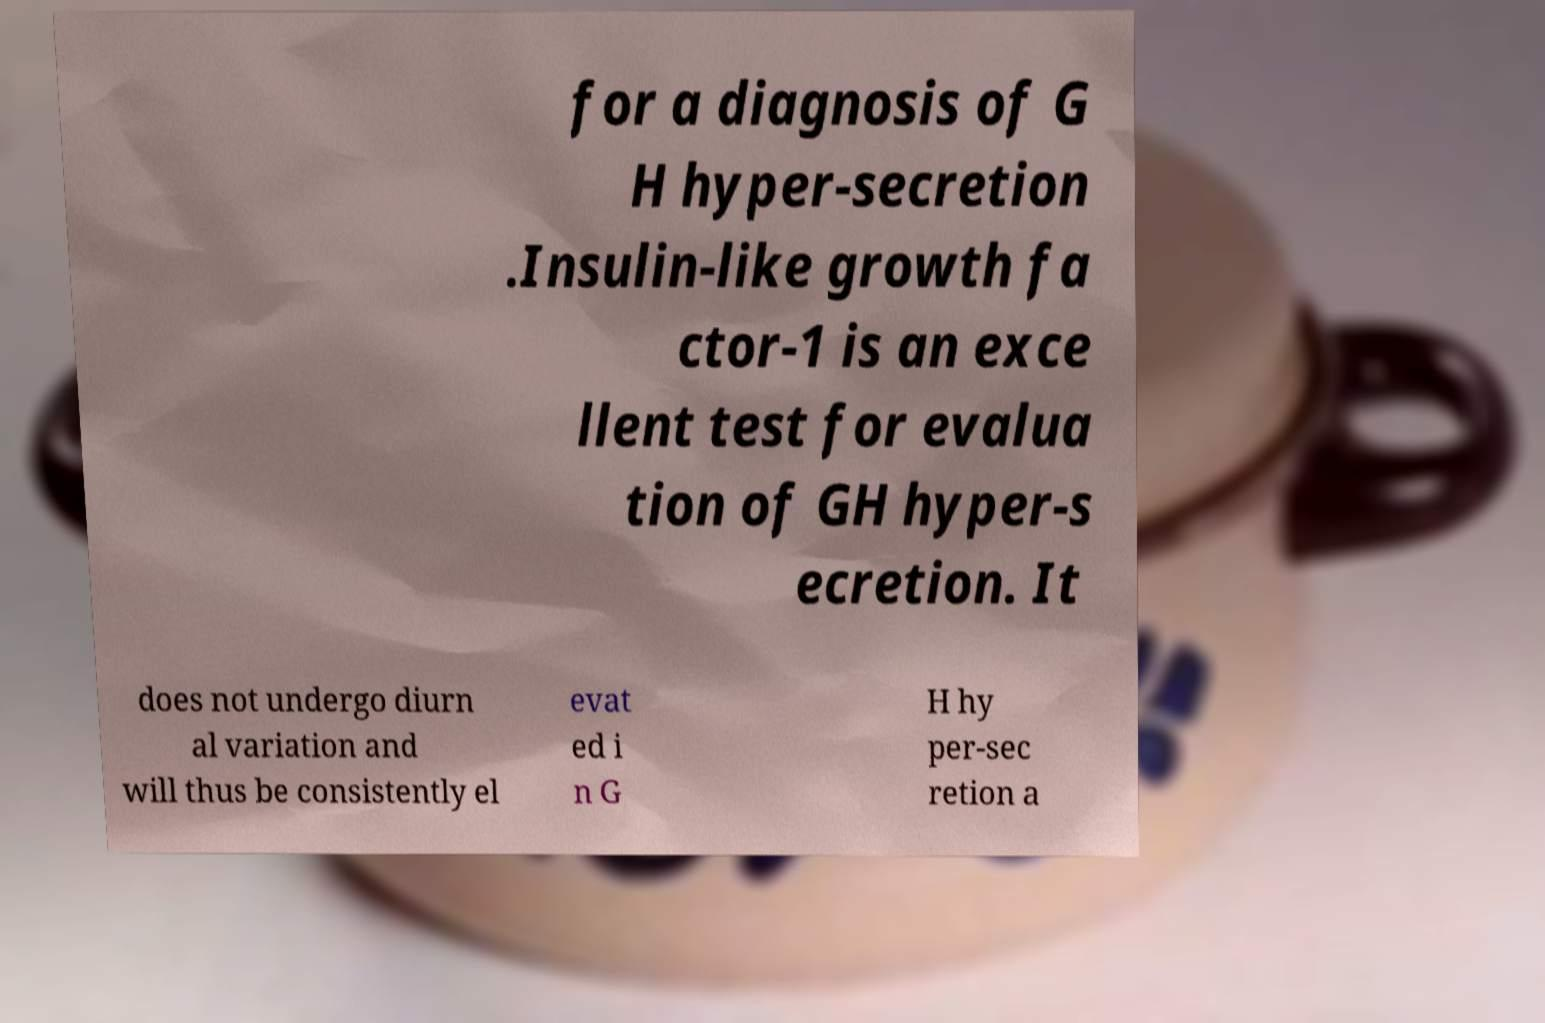There's text embedded in this image that I need extracted. Can you transcribe it verbatim? for a diagnosis of G H hyper-secretion .Insulin-like growth fa ctor-1 is an exce llent test for evalua tion of GH hyper-s ecretion. It does not undergo diurn al variation and will thus be consistently el evat ed i n G H hy per-sec retion a 